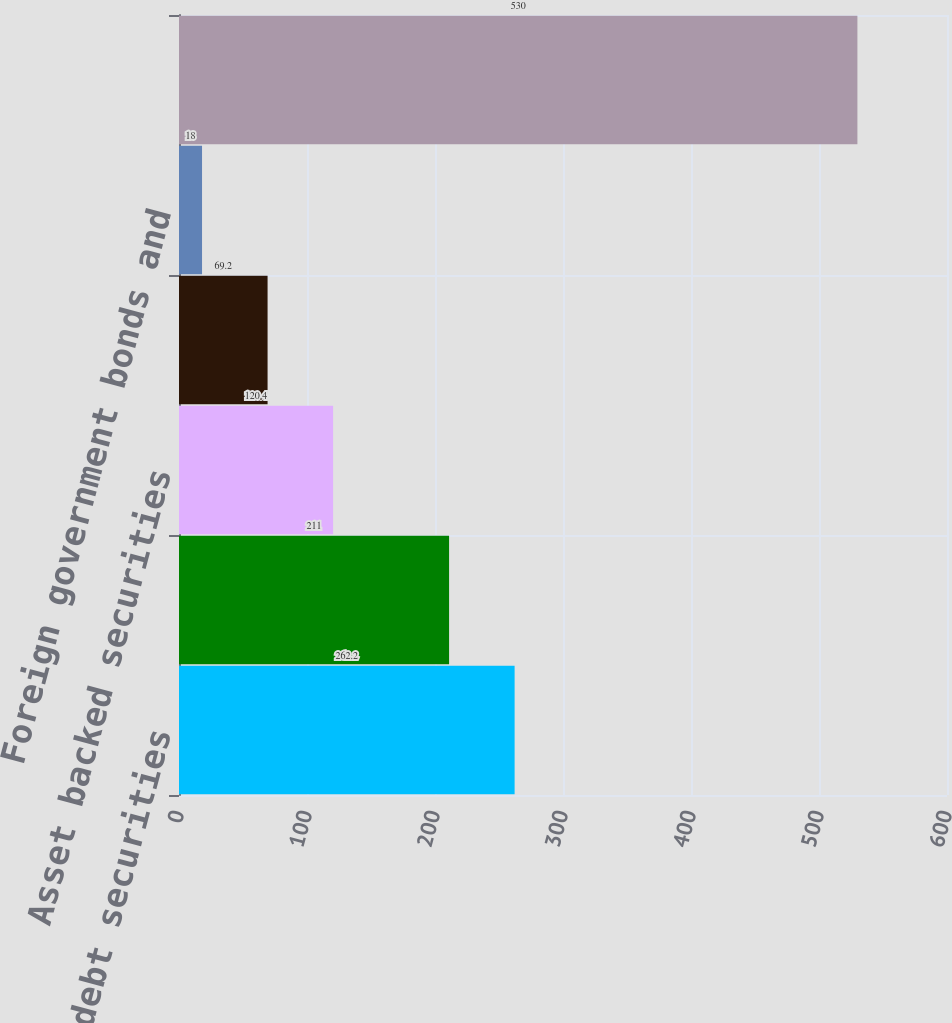Convert chart to OTSL. <chart><loc_0><loc_0><loc_500><loc_500><bar_chart><fcel>Corporate debt securities<fcel>Residential mortgage backed<fcel>Asset backed securities<fcel>State and municipal<fcel>Foreign government bonds and<fcel>Total<nl><fcel>262.2<fcel>211<fcel>120.4<fcel>69.2<fcel>18<fcel>530<nl></chart> 